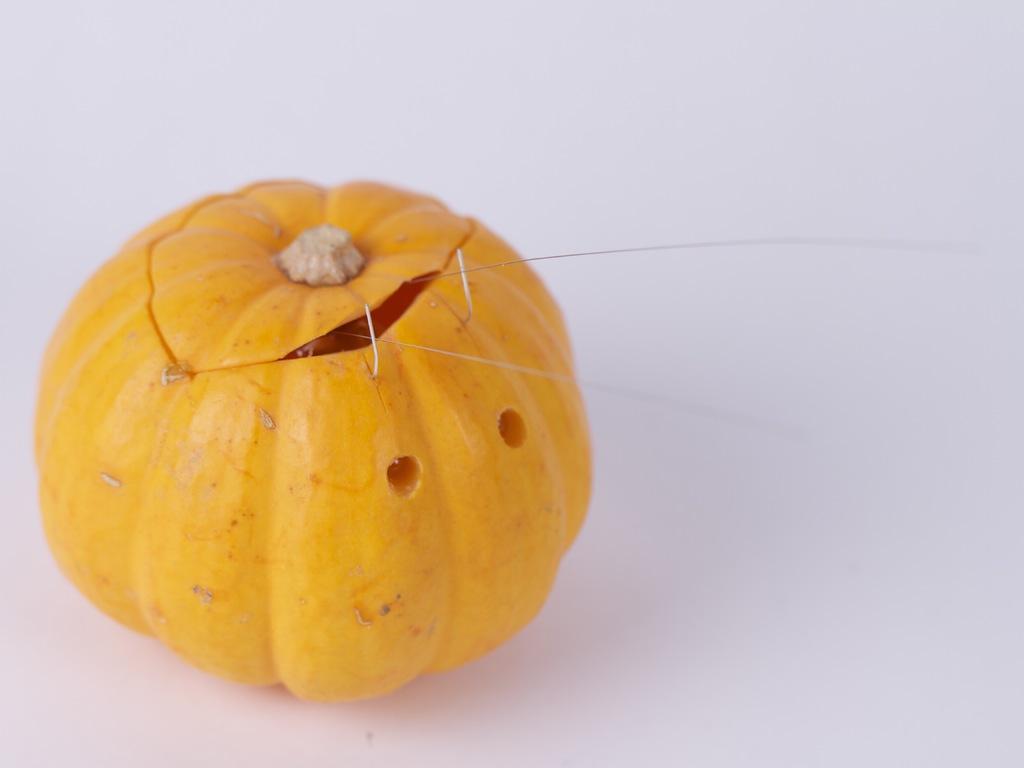Please provide a concise description of this image. In this image, on the left there is a pumpkin. 